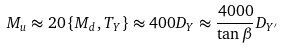Convert formula to latex. <formula><loc_0><loc_0><loc_500><loc_500>M _ { u } \approx 2 0 \, \{ M _ { d } , T _ { Y } \} \approx 4 0 0 D _ { Y } \approx \frac { 4 0 0 0 } { \tan \beta } D _ { Y ^ { \prime } }</formula> 